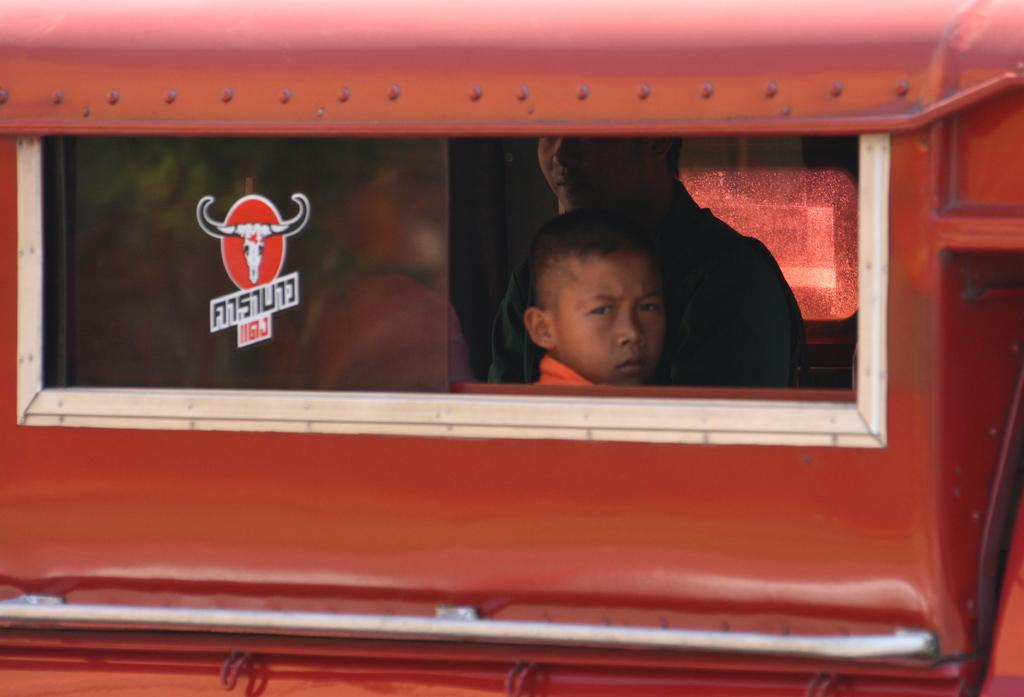What is happening in the image? There are persons sitting inside a vehicle. Can you describe any additional details about the vehicle? There is a sticker on the window glass of the vehicle. What type of cheese is being used in the protest depicted in the image? There is no protest or cheese present in the image; it only shows persons sitting inside a vehicle with a sticker on the window glass. 